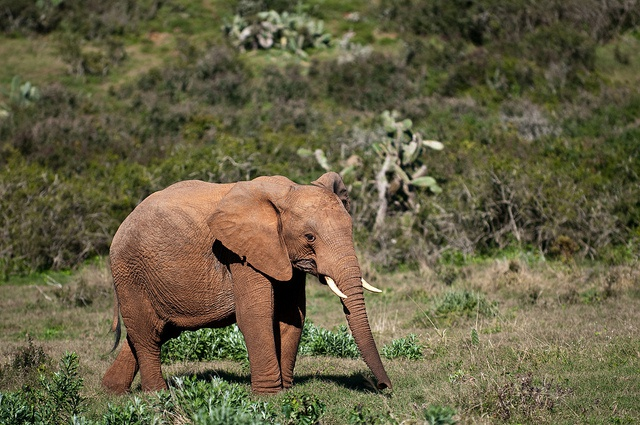Describe the objects in this image and their specific colors. I can see a elephant in black, brown, and tan tones in this image. 